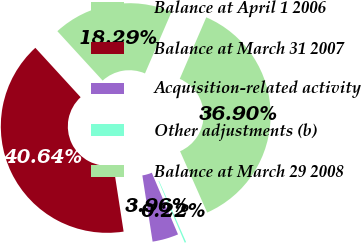Convert chart to OTSL. <chart><loc_0><loc_0><loc_500><loc_500><pie_chart><fcel>Balance at April 1 2006<fcel>Balance at March 31 2007<fcel>Acquisition-related activity<fcel>Other adjustments (b)<fcel>Balance at March 29 2008<nl><fcel>18.29%<fcel>40.64%<fcel>3.96%<fcel>0.22%<fcel>36.9%<nl></chart> 